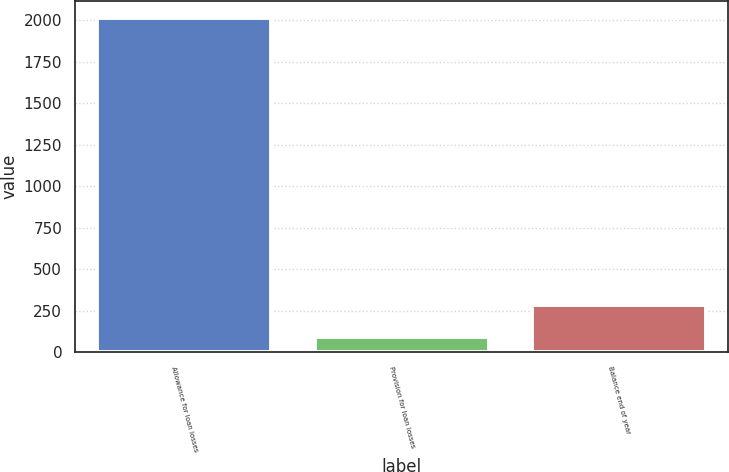<chart> <loc_0><loc_0><loc_500><loc_500><bar_chart><fcel>Allowance for loan losses<fcel>Provision for loan losses<fcel>Balance end of year<nl><fcel>2014<fcel>92<fcel>284.2<nl></chart> 